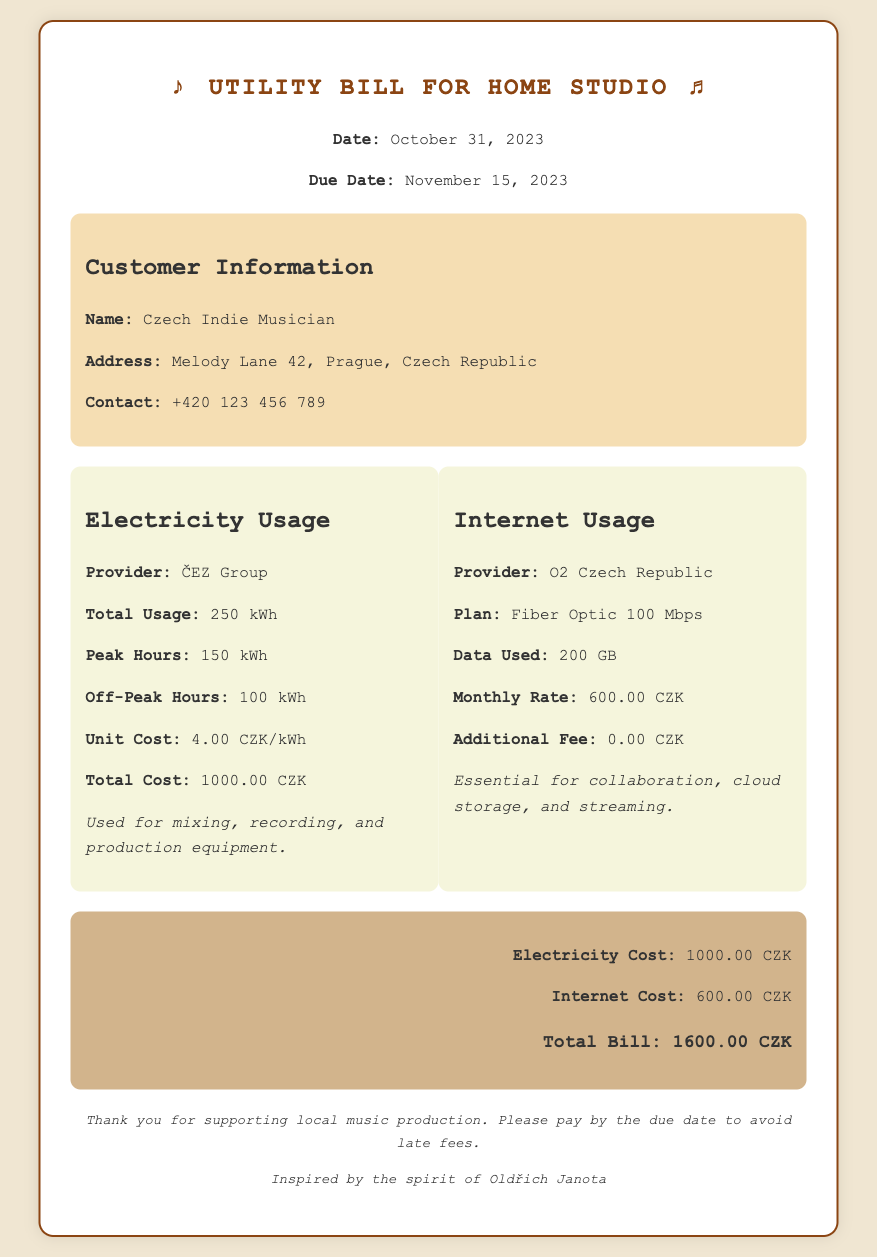what is the total usage of electricity? The total usage of electricity is specified in the usage details section.
Answer: 250 kWh what is the due date for the bill? The due date is mentioned in the header of the document.
Answer: November 15, 2023 how much was the unit cost for electricity? The unit cost is found in the electricity usage details.
Answer: 4.00 CZK/kWh what is the data used for internet? The data used for internet is stated in the internet usage section.
Answer: 200 GB what is the total cost for internet? The total cost for internet is outlined in the internet usage box.
Answer: 600.00 CZK how much electricity was used during peak hours? The peak hours usage is mentioned in the electricity usage details.
Answer: 150 kWh what is the total bill amount? The total bill is calculated in the summary section of the document.
Answer: 1600.00 CZK which provider supplies the electricity? The electricity provider is listed in the electricity usage section.
Answer: ČEZ Group what is the essential use of the internet mentioned? The use of the internet is described in the internet usage box.
Answer: Collaboration, cloud storage, and streaming 